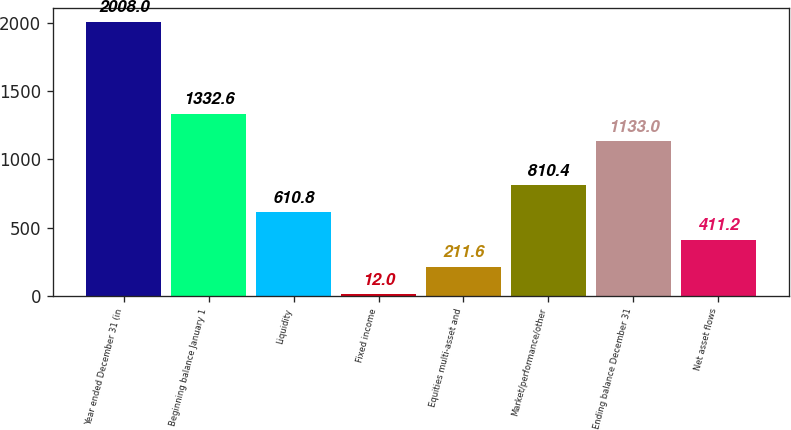Convert chart. <chart><loc_0><loc_0><loc_500><loc_500><bar_chart><fcel>Year ended December 31 (in<fcel>Beginning balance January 1<fcel>Liquidity<fcel>Fixed income<fcel>Equities multi-asset and<fcel>Market/performance/other<fcel>Ending balance December 31<fcel>Net asset flows<nl><fcel>2008<fcel>1332.6<fcel>610.8<fcel>12<fcel>211.6<fcel>810.4<fcel>1133<fcel>411.2<nl></chart> 